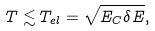Convert formula to latex. <formula><loc_0><loc_0><loc_500><loc_500>T \lesssim T _ { e l } = \sqrt { E _ { C } \delta E } ,</formula> 